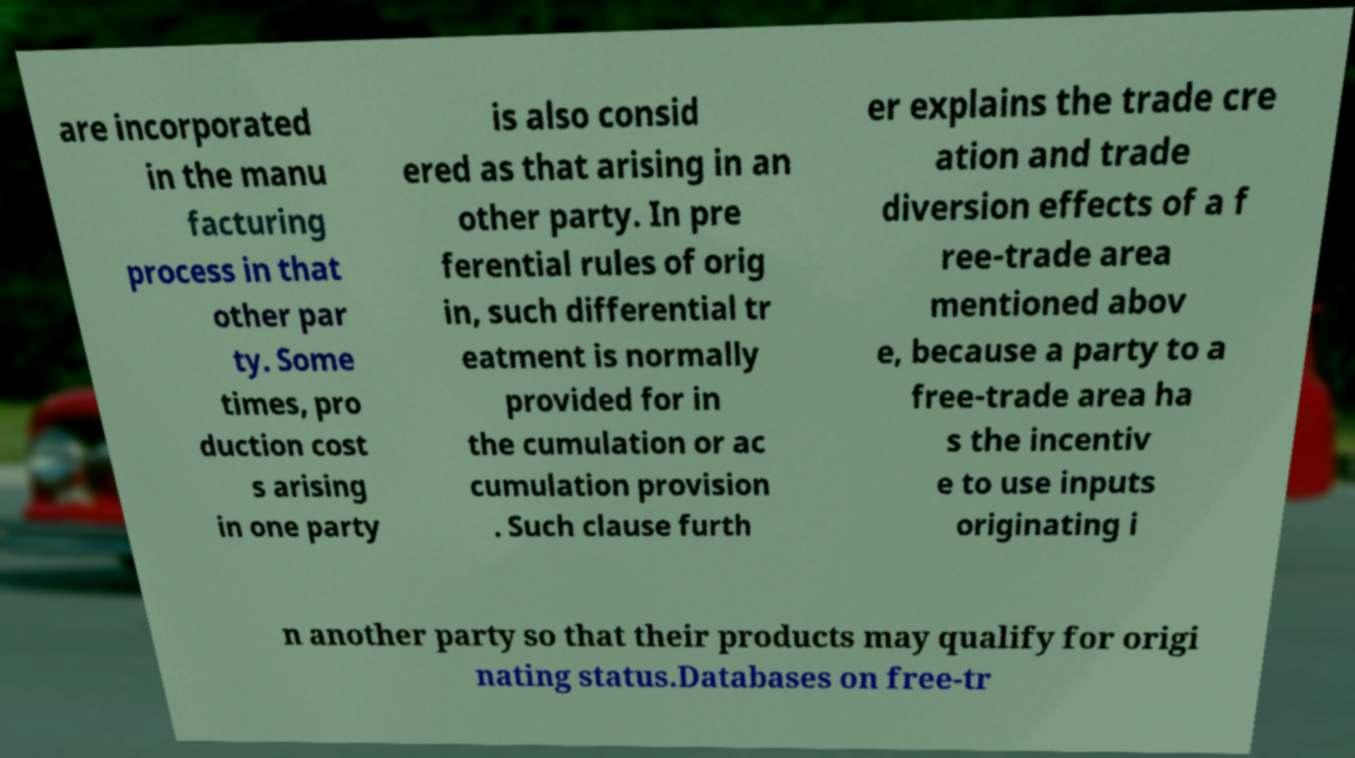Please identify and transcribe the text found in this image. are incorporated in the manu facturing process in that other par ty. Some times, pro duction cost s arising in one party is also consid ered as that arising in an other party. In pre ferential rules of orig in, such differential tr eatment is normally provided for in the cumulation or ac cumulation provision . Such clause furth er explains the trade cre ation and trade diversion effects of a f ree-trade area mentioned abov e, because a party to a free-trade area ha s the incentiv e to use inputs originating i n another party so that their products may qualify for origi nating status.Databases on free-tr 